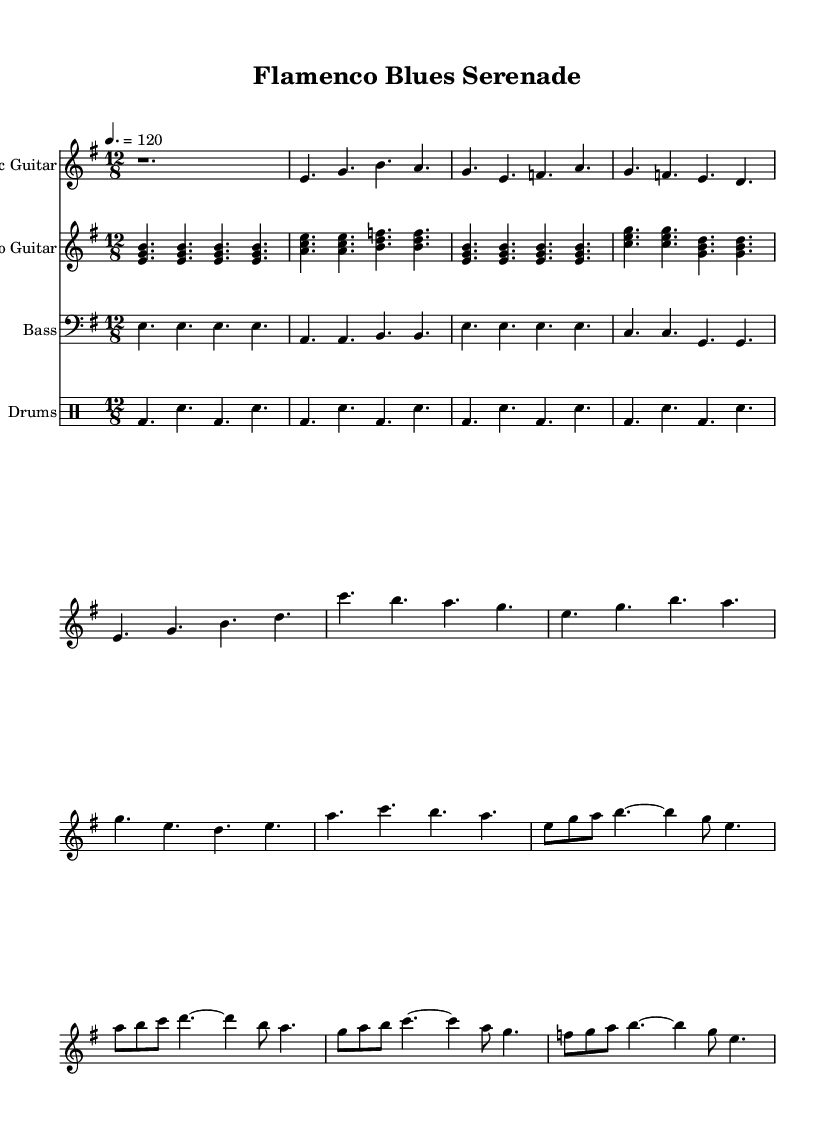What is the key signature of this music? The key signature indicated at the beginning of the score is E minor, which consists of one sharp (F#). E minor is the relative minor of G major.
Answer: E minor What is the time signature of this piece? The time signature is shown as 12/8, which means there are 12 eighth notes per measure. This time signature is commonly used in blues and flamenco music for a lilting feel.
Answer: 12/8 What is the tempo marking for this composition? The tempo marking is indicated as 4. = 120, which specifies that the quarter note should be played at a speed of 120 beats per minute. This is a moderate pace typical for electric blues.
Answer: 120 How many different instruments are featured in this piece? The score lists four distinct parts: electric guitar, flamenco guitar, bass, and drums. Each instrument is notated on its own staff, highlighting their unique contributions.
Answer: Four What is the primary style of the guitar parts in this score? Both guitar parts prominently feature a combination of electric blues elements and flamenco chord structures. The electric guitar employs rhythmic and melodic ideas typical of electric blues, while the flamenco guitar uses traditional flamenco chords.
Answer: Flamenco blues Which section of the piece contains a solo? The score indicates that a solo occurs after the verse and chorus sections. This section provides room for improvisation, a key characteristic of electric blues. The solo utilizes simplified melodic lines to allow for expressive playing.
Answer: Solo 